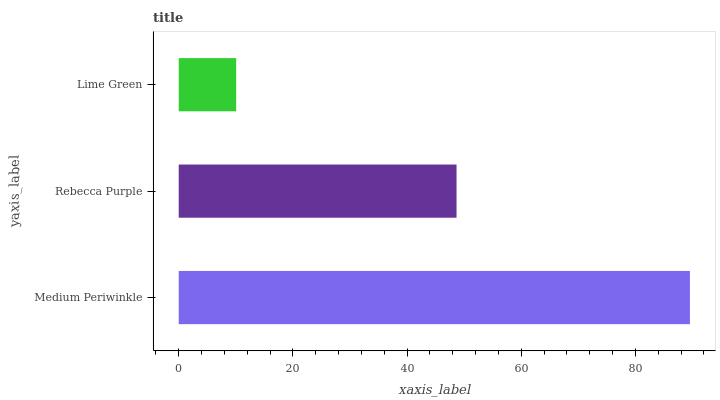Is Lime Green the minimum?
Answer yes or no. Yes. Is Medium Periwinkle the maximum?
Answer yes or no. Yes. Is Rebecca Purple the minimum?
Answer yes or no. No. Is Rebecca Purple the maximum?
Answer yes or no. No. Is Medium Periwinkle greater than Rebecca Purple?
Answer yes or no. Yes. Is Rebecca Purple less than Medium Periwinkle?
Answer yes or no. Yes. Is Rebecca Purple greater than Medium Periwinkle?
Answer yes or no. No. Is Medium Periwinkle less than Rebecca Purple?
Answer yes or no. No. Is Rebecca Purple the high median?
Answer yes or no. Yes. Is Rebecca Purple the low median?
Answer yes or no. Yes. Is Medium Periwinkle the high median?
Answer yes or no. No. Is Lime Green the low median?
Answer yes or no. No. 